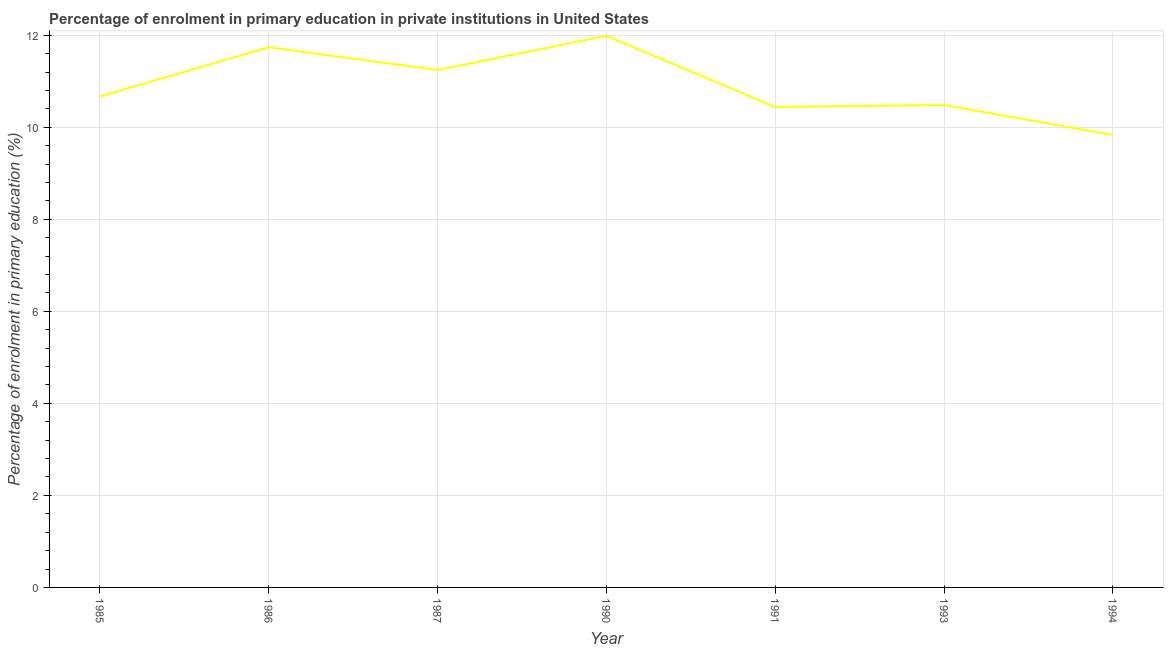What is the enrolment percentage in primary education in 1993?
Offer a very short reply. 10.49. Across all years, what is the maximum enrolment percentage in primary education?
Your answer should be compact. 11.99. Across all years, what is the minimum enrolment percentage in primary education?
Your response must be concise. 9.83. In which year was the enrolment percentage in primary education maximum?
Offer a terse response. 1990. What is the sum of the enrolment percentage in primary education?
Make the answer very short. 76.4. What is the difference between the enrolment percentage in primary education in 1990 and 1993?
Offer a terse response. 1.5. What is the average enrolment percentage in primary education per year?
Offer a terse response. 10.91. What is the median enrolment percentage in primary education?
Your response must be concise. 10.67. In how many years, is the enrolment percentage in primary education greater than 8.4 %?
Keep it short and to the point. 7. What is the ratio of the enrolment percentage in primary education in 1985 to that in 1994?
Offer a terse response. 1.09. Is the difference between the enrolment percentage in primary education in 1985 and 1994 greater than the difference between any two years?
Provide a short and direct response. No. What is the difference between the highest and the second highest enrolment percentage in primary education?
Make the answer very short. 0.25. Is the sum of the enrolment percentage in primary education in 1986 and 1990 greater than the maximum enrolment percentage in primary education across all years?
Your answer should be compact. Yes. What is the difference between the highest and the lowest enrolment percentage in primary education?
Ensure brevity in your answer.  2.16. In how many years, is the enrolment percentage in primary education greater than the average enrolment percentage in primary education taken over all years?
Keep it short and to the point. 3. How many years are there in the graph?
Ensure brevity in your answer.  7. What is the title of the graph?
Provide a short and direct response. Percentage of enrolment in primary education in private institutions in United States. What is the label or title of the X-axis?
Your response must be concise. Year. What is the label or title of the Y-axis?
Provide a succinct answer. Percentage of enrolment in primary education (%). What is the Percentage of enrolment in primary education (%) in 1985?
Provide a succinct answer. 10.67. What is the Percentage of enrolment in primary education (%) in 1986?
Offer a terse response. 11.74. What is the Percentage of enrolment in primary education (%) in 1987?
Offer a terse response. 11.25. What is the Percentage of enrolment in primary education (%) in 1990?
Keep it short and to the point. 11.99. What is the Percentage of enrolment in primary education (%) of 1991?
Provide a succinct answer. 10.44. What is the Percentage of enrolment in primary education (%) of 1993?
Provide a succinct answer. 10.49. What is the Percentage of enrolment in primary education (%) in 1994?
Provide a short and direct response. 9.83. What is the difference between the Percentage of enrolment in primary education (%) in 1985 and 1986?
Provide a short and direct response. -1.07. What is the difference between the Percentage of enrolment in primary education (%) in 1985 and 1987?
Your response must be concise. -0.58. What is the difference between the Percentage of enrolment in primary education (%) in 1985 and 1990?
Keep it short and to the point. -1.32. What is the difference between the Percentage of enrolment in primary education (%) in 1985 and 1991?
Provide a short and direct response. 0.23. What is the difference between the Percentage of enrolment in primary education (%) in 1985 and 1993?
Provide a succinct answer. 0.18. What is the difference between the Percentage of enrolment in primary education (%) in 1985 and 1994?
Offer a very short reply. 0.84. What is the difference between the Percentage of enrolment in primary education (%) in 1986 and 1987?
Make the answer very short. 0.49. What is the difference between the Percentage of enrolment in primary education (%) in 1986 and 1990?
Make the answer very short. -0.25. What is the difference between the Percentage of enrolment in primary education (%) in 1986 and 1991?
Make the answer very short. 1.3. What is the difference between the Percentage of enrolment in primary education (%) in 1986 and 1993?
Your answer should be very brief. 1.25. What is the difference between the Percentage of enrolment in primary education (%) in 1986 and 1994?
Your answer should be very brief. 1.91. What is the difference between the Percentage of enrolment in primary education (%) in 1987 and 1990?
Offer a very short reply. -0.74. What is the difference between the Percentage of enrolment in primary education (%) in 1987 and 1991?
Keep it short and to the point. 0.8. What is the difference between the Percentage of enrolment in primary education (%) in 1987 and 1993?
Offer a terse response. 0.76. What is the difference between the Percentage of enrolment in primary education (%) in 1987 and 1994?
Your answer should be very brief. 1.41. What is the difference between the Percentage of enrolment in primary education (%) in 1990 and 1991?
Provide a short and direct response. 1.55. What is the difference between the Percentage of enrolment in primary education (%) in 1990 and 1993?
Offer a terse response. 1.5. What is the difference between the Percentage of enrolment in primary education (%) in 1990 and 1994?
Your response must be concise. 2.16. What is the difference between the Percentage of enrolment in primary education (%) in 1991 and 1993?
Offer a terse response. -0.04. What is the difference between the Percentage of enrolment in primary education (%) in 1991 and 1994?
Ensure brevity in your answer.  0.61. What is the difference between the Percentage of enrolment in primary education (%) in 1993 and 1994?
Give a very brief answer. 0.65. What is the ratio of the Percentage of enrolment in primary education (%) in 1985 to that in 1986?
Offer a terse response. 0.91. What is the ratio of the Percentage of enrolment in primary education (%) in 1985 to that in 1987?
Provide a succinct answer. 0.95. What is the ratio of the Percentage of enrolment in primary education (%) in 1985 to that in 1990?
Your answer should be compact. 0.89. What is the ratio of the Percentage of enrolment in primary education (%) in 1985 to that in 1991?
Make the answer very short. 1.02. What is the ratio of the Percentage of enrolment in primary education (%) in 1985 to that in 1993?
Your response must be concise. 1.02. What is the ratio of the Percentage of enrolment in primary education (%) in 1985 to that in 1994?
Your answer should be very brief. 1.08. What is the ratio of the Percentage of enrolment in primary education (%) in 1986 to that in 1987?
Provide a succinct answer. 1.04. What is the ratio of the Percentage of enrolment in primary education (%) in 1986 to that in 1991?
Keep it short and to the point. 1.12. What is the ratio of the Percentage of enrolment in primary education (%) in 1986 to that in 1993?
Provide a short and direct response. 1.12. What is the ratio of the Percentage of enrolment in primary education (%) in 1986 to that in 1994?
Offer a very short reply. 1.19. What is the ratio of the Percentage of enrolment in primary education (%) in 1987 to that in 1990?
Ensure brevity in your answer.  0.94. What is the ratio of the Percentage of enrolment in primary education (%) in 1987 to that in 1991?
Give a very brief answer. 1.08. What is the ratio of the Percentage of enrolment in primary education (%) in 1987 to that in 1993?
Ensure brevity in your answer.  1.07. What is the ratio of the Percentage of enrolment in primary education (%) in 1987 to that in 1994?
Provide a short and direct response. 1.14. What is the ratio of the Percentage of enrolment in primary education (%) in 1990 to that in 1991?
Give a very brief answer. 1.15. What is the ratio of the Percentage of enrolment in primary education (%) in 1990 to that in 1993?
Offer a very short reply. 1.14. What is the ratio of the Percentage of enrolment in primary education (%) in 1990 to that in 1994?
Keep it short and to the point. 1.22. What is the ratio of the Percentage of enrolment in primary education (%) in 1991 to that in 1994?
Your answer should be very brief. 1.06. What is the ratio of the Percentage of enrolment in primary education (%) in 1993 to that in 1994?
Offer a very short reply. 1.07. 